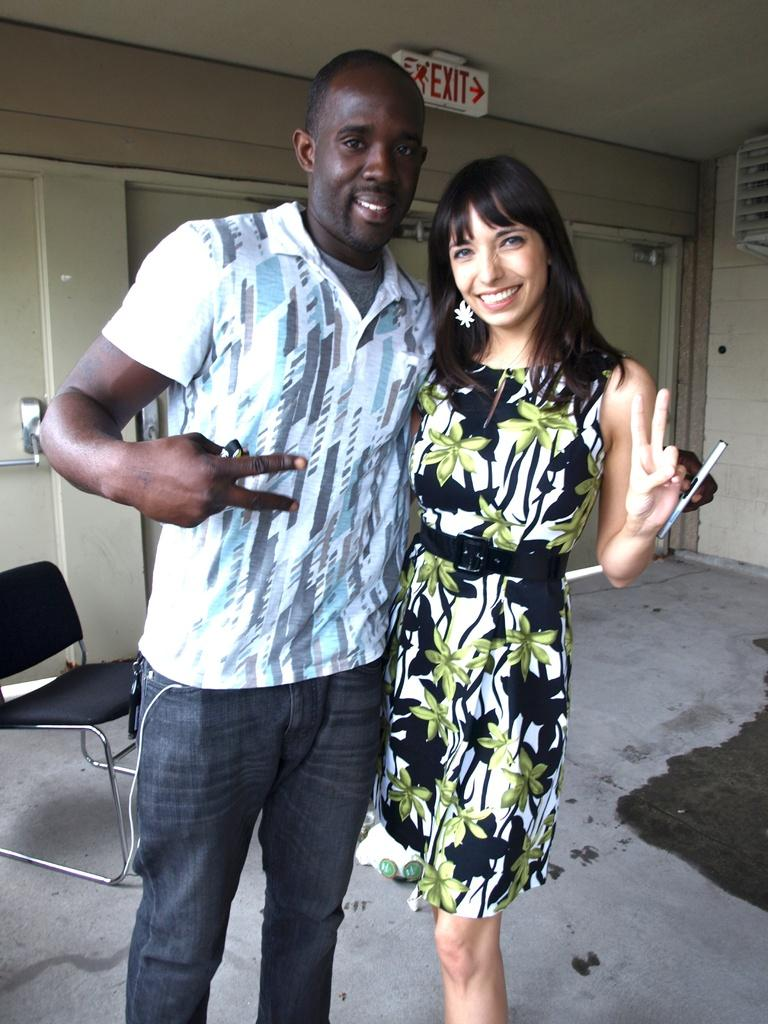Who is present in the image? There is a man and a woman in the image. What are the expressions on their faces? Both the man and woman are smiling in the image. What can be seen on the wall in the image? There is an exit board in the image. What type of furniture is present in the image? There is a chair in the image. Can you see any hills in the image? There are no hills visible in the image. What type of arch can be seen in the image? There is no arch present in the image. 